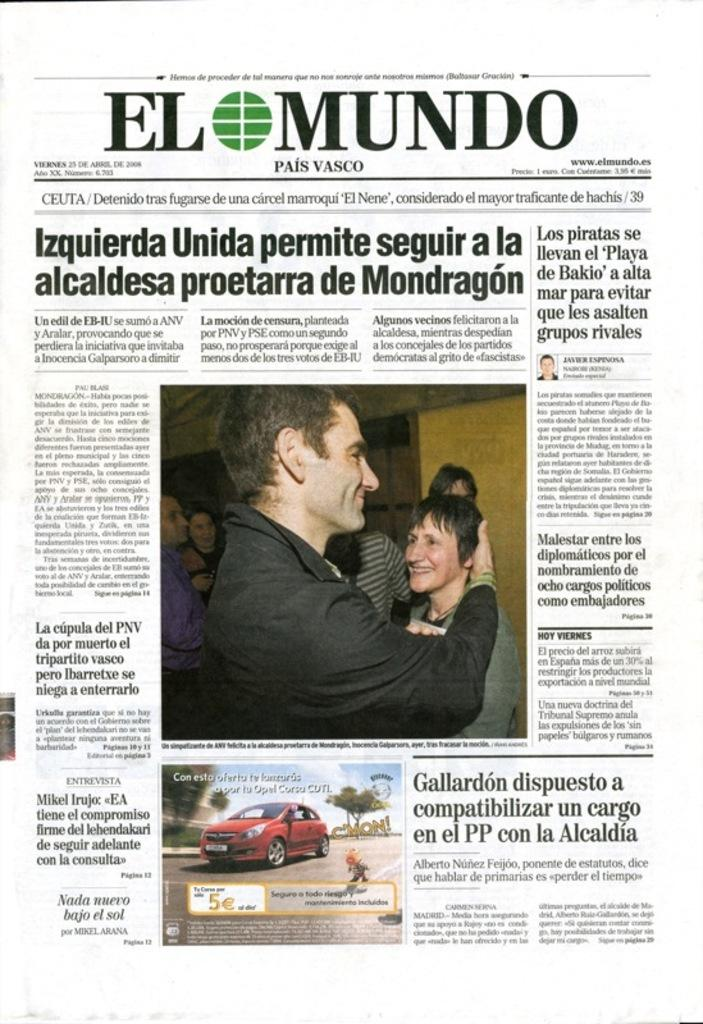What is the main subject of the paper in the image? The paper contains images of men and women, as well as an image of a car. What else can be found on the paper besides the images? There is text on the paper. What is the weight of the car in the image? The weight of the car cannot be determined from the image, as it only contains a two-dimensional representation of the car. 